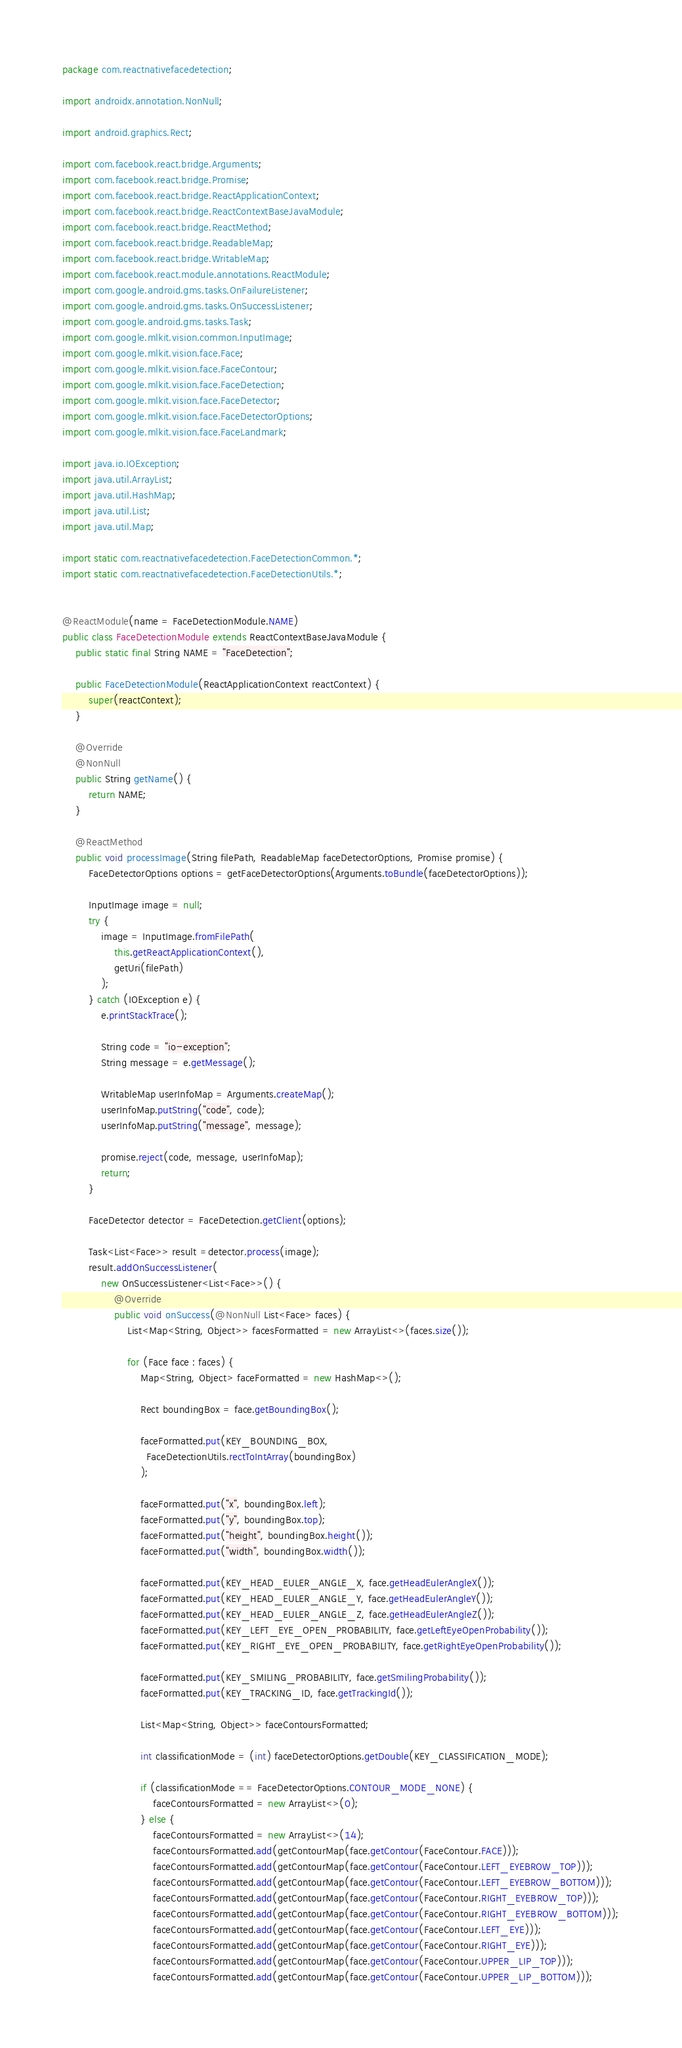Convert code to text. <code><loc_0><loc_0><loc_500><loc_500><_Java_>package com.reactnativefacedetection;

import androidx.annotation.NonNull;

import android.graphics.Rect;

import com.facebook.react.bridge.Arguments;
import com.facebook.react.bridge.Promise;
import com.facebook.react.bridge.ReactApplicationContext;
import com.facebook.react.bridge.ReactContextBaseJavaModule;
import com.facebook.react.bridge.ReactMethod;
import com.facebook.react.bridge.ReadableMap;
import com.facebook.react.bridge.WritableMap;
import com.facebook.react.module.annotations.ReactModule;
import com.google.android.gms.tasks.OnFailureListener;
import com.google.android.gms.tasks.OnSuccessListener;
import com.google.android.gms.tasks.Task;
import com.google.mlkit.vision.common.InputImage;
import com.google.mlkit.vision.face.Face;
import com.google.mlkit.vision.face.FaceContour;
import com.google.mlkit.vision.face.FaceDetection;
import com.google.mlkit.vision.face.FaceDetector;
import com.google.mlkit.vision.face.FaceDetectorOptions;
import com.google.mlkit.vision.face.FaceLandmark;

import java.io.IOException;
import java.util.ArrayList;
import java.util.HashMap;
import java.util.List;
import java.util.Map;

import static com.reactnativefacedetection.FaceDetectionCommon.*;
import static com.reactnativefacedetection.FaceDetectionUtils.*;


@ReactModule(name = FaceDetectionModule.NAME)
public class FaceDetectionModule extends ReactContextBaseJavaModule {
    public static final String NAME = "FaceDetection";

    public FaceDetectionModule(ReactApplicationContext reactContext) {
        super(reactContext);
    }

    @Override
    @NonNull
    public String getName() {
        return NAME;
    }

    @ReactMethod
    public void processImage(String filePath, ReadableMap faceDetectorOptions, Promise promise) {
        FaceDetectorOptions options = getFaceDetectorOptions(Arguments.toBundle(faceDetectorOptions));

        InputImage image = null;
        try {
            image = InputImage.fromFilePath(
                this.getReactApplicationContext(),
                getUri(filePath)
            );
        } catch (IOException e) {
            e.printStackTrace();

            String code = "io-exception";
            String message = e.getMessage();

            WritableMap userInfoMap = Arguments.createMap();
            userInfoMap.putString("code", code);
            userInfoMap.putString("message", message);

            promise.reject(code, message, userInfoMap);
            return;
        }

        FaceDetector detector = FaceDetection.getClient(options);

        Task<List<Face>> result =detector.process(image);
        result.addOnSuccessListener(
            new OnSuccessListener<List<Face>>() {
                @Override
                public void onSuccess(@NonNull List<Face> faces) {
                    List<Map<String, Object>> facesFormatted = new ArrayList<>(faces.size());

                    for (Face face : faces) {
                        Map<String, Object> faceFormatted = new HashMap<>();

                        Rect boundingBox = face.getBoundingBox();

                        faceFormatted.put(KEY_BOUNDING_BOX,
                          FaceDetectionUtils.rectToIntArray(boundingBox)
                        );                        

                        faceFormatted.put("x", boundingBox.left);
                        faceFormatted.put("y", boundingBox.top);
                        faceFormatted.put("height", boundingBox.height());
                        faceFormatted.put("width", boundingBox.width());

                        faceFormatted.put(KEY_HEAD_EULER_ANGLE_X, face.getHeadEulerAngleX());
                        faceFormatted.put(KEY_HEAD_EULER_ANGLE_Y, face.getHeadEulerAngleY());
                        faceFormatted.put(KEY_HEAD_EULER_ANGLE_Z, face.getHeadEulerAngleZ());
                        faceFormatted.put(KEY_LEFT_EYE_OPEN_PROBABILITY, face.getLeftEyeOpenProbability());
                        faceFormatted.put(KEY_RIGHT_EYE_OPEN_PROBABILITY, face.getRightEyeOpenProbability());

                        faceFormatted.put(KEY_SMILING_PROBABILITY, face.getSmilingProbability());
                        faceFormatted.put(KEY_TRACKING_ID, face.getTrackingId());

                        List<Map<String, Object>> faceContoursFormatted;

                        int classificationMode = (int) faceDetectorOptions.getDouble(KEY_CLASSIFICATION_MODE);

                        if (classificationMode == FaceDetectorOptions.CONTOUR_MODE_NONE) {
                            faceContoursFormatted = new ArrayList<>(0);
                        } else {
                            faceContoursFormatted = new ArrayList<>(14);
                            faceContoursFormatted.add(getContourMap(face.getContour(FaceContour.FACE)));
                            faceContoursFormatted.add(getContourMap(face.getContour(FaceContour.LEFT_EYEBROW_TOP)));
                            faceContoursFormatted.add(getContourMap(face.getContour(FaceContour.LEFT_EYEBROW_BOTTOM)));
                            faceContoursFormatted.add(getContourMap(face.getContour(FaceContour.RIGHT_EYEBROW_TOP)));
                            faceContoursFormatted.add(getContourMap(face.getContour(FaceContour.RIGHT_EYEBROW_BOTTOM)));
                            faceContoursFormatted.add(getContourMap(face.getContour(FaceContour.LEFT_EYE)));
                            faceContoursFormatted.add(getContourMap(face.getContour(FaceContour.RIGHT_EYE)));
                            faceContoursFormatted.add(getContourMap(face.getContour(FaceContour.UPPER_LIP_TOP)));
                            faceContoursFormatted.add(getContourMap(face.getContour(FaceContour.UPPER_LIP_BOTTOM)));</code> 